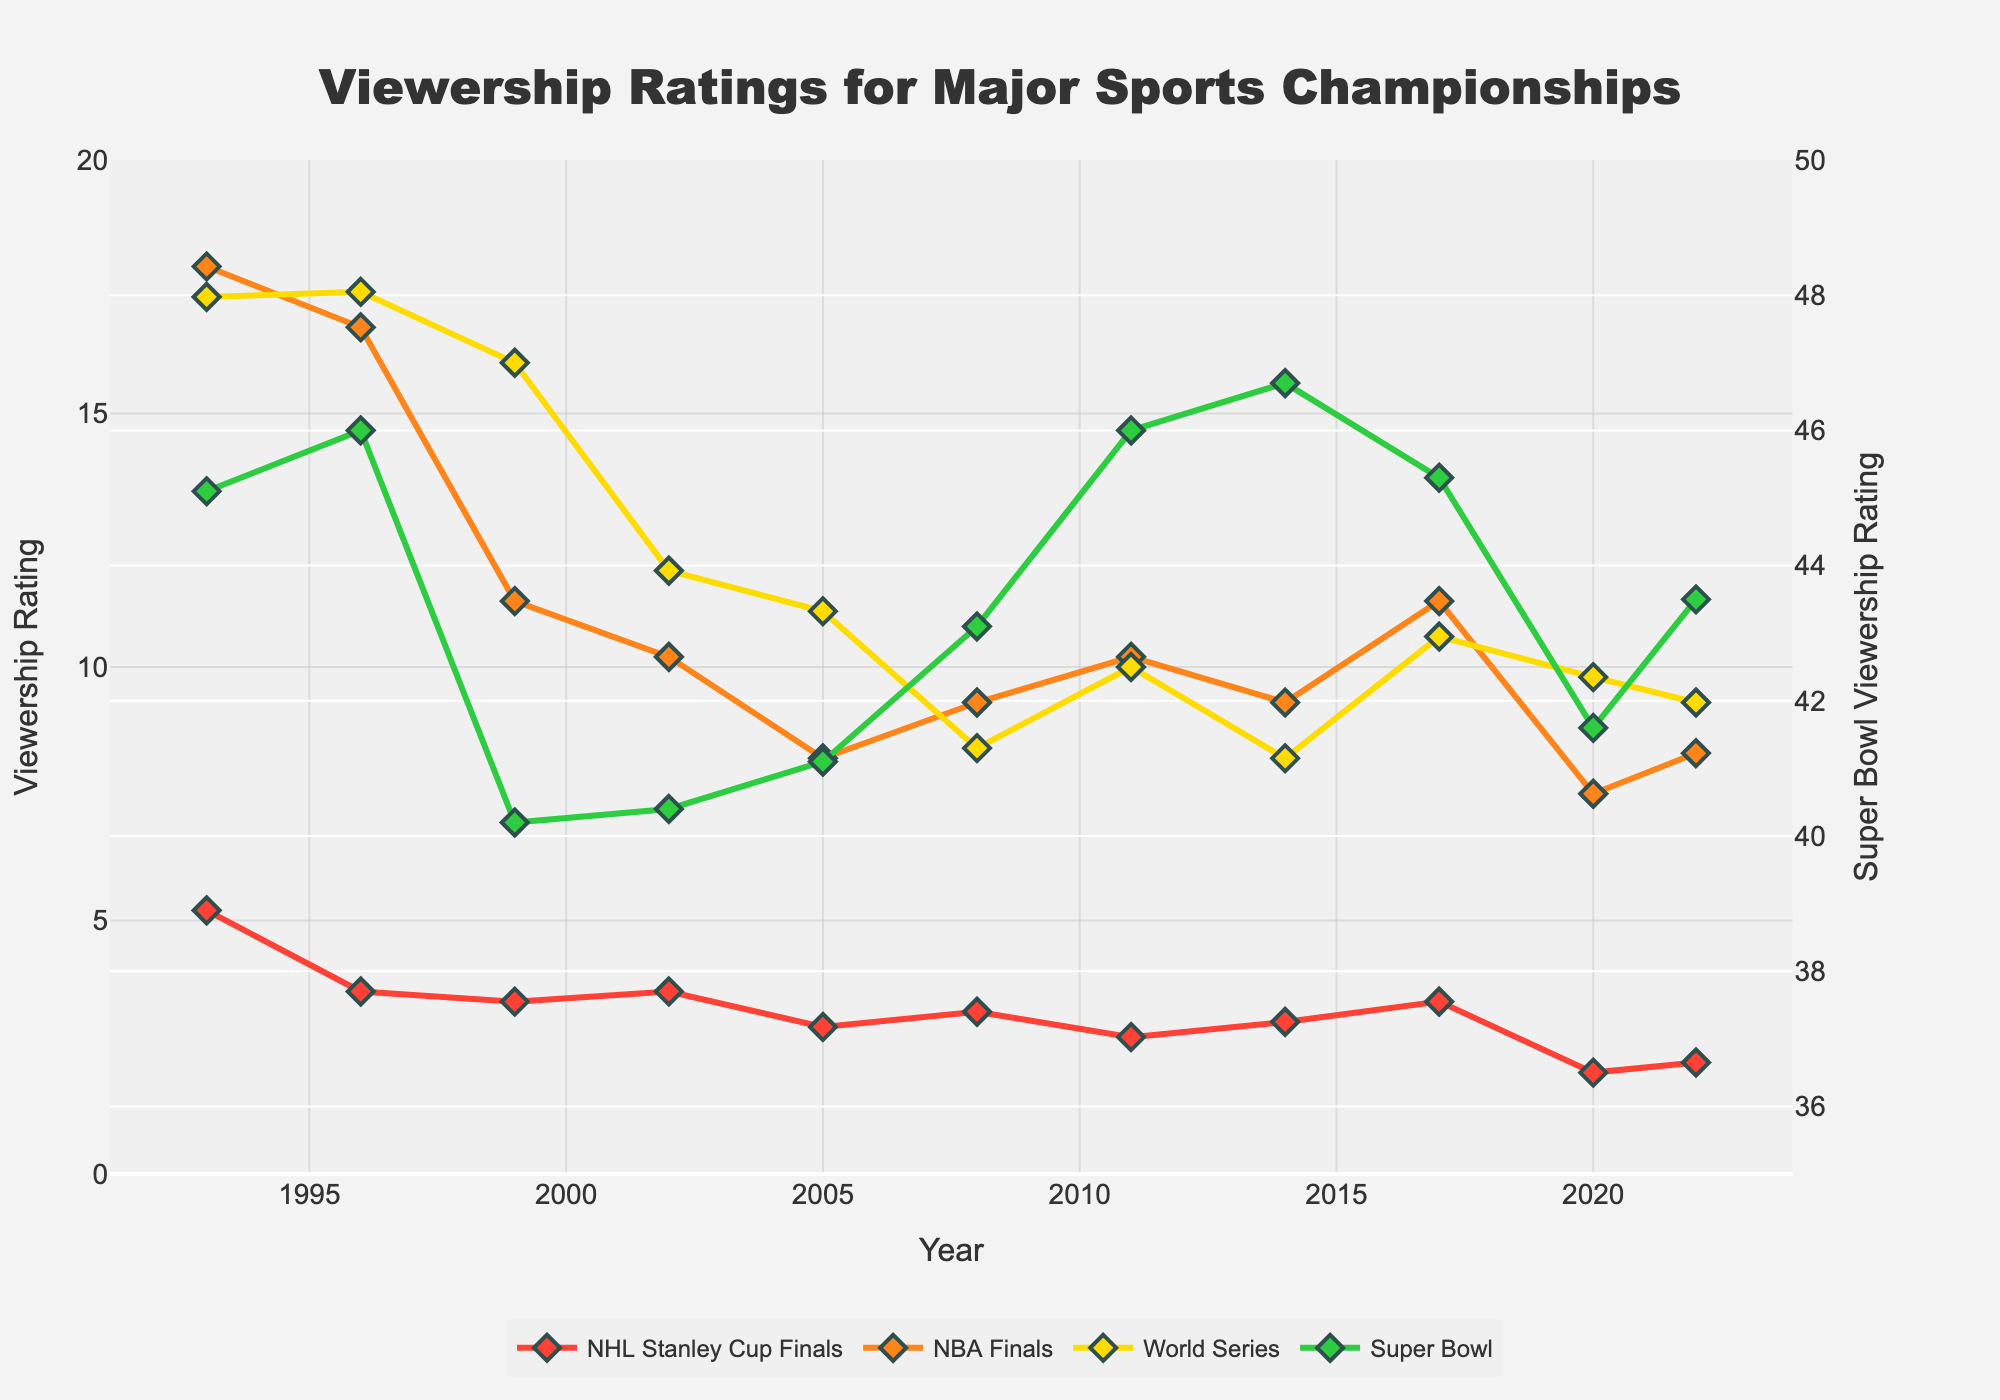Which sport has the highest viewership rating in 2020? To determine the sport with the highest viewership in 2020, look at the data points for each sport in that year on the figure. The Super Bowl has the highest viewership rating of 41.6.
Answer: Super Bowl Between 1996 and 1999, did the NBA Finals viewership increase or decrease, and by how much? To determine the change in NBA Finals viewership from 1996 to 1999, look at the viewership ratings for those years. In 1996, it was 16.7, and in 1999, it was 11.3. So, it decreased by 16.7 - 11.3 = 5.4.
Answer: Decrease by 5.4 What is the average viewership rating for the NHL Stanley Cup Finals from 2002 to 2020? To find the average, add the viewership ratings from 2002 to 2020 and divide by the number of years. (3.6 + 2.9 + 3.2 + 2.7 + 3.0 + 3.4 + 2.0 + 2.2)/8 = 23.0 / 8 = 2.875
Answer: 2.875 Which sport shows the most dramatic decline in viewership from 1993 to 2022? To determine the sport with the most dramatic decline, compare the overall drop for each sport over this period. The NHL Stanley Cup Finals declined from 5.2 in 1993 to 2.2 in 2022, which is a drop of 3.0. The Super Bowl dropped by 1.6 (45.1 to 43.5), the NBA Finals dropped by 9.6 (17.9 to 8.3), and the World Series dropped by 8.0 (17.3 to 9.3). The NBA Finals shows the most significant drop.
Answer: NBA Finals How does the viewership trend for the Super Bowl differ from the trends of the other sports? Look at the lines representing each sport. The Super Bowl maintains a relatively high and stable viewership, with a slight decline in recent years. In contrast, the other sports, especially the NBA Finals and World Series, show a more noticeable decline in viewership over time.
Answer: Super Bowl is stable, others declined Which championship had the lowest viewership rating in 2020? Check the viewership ratings in 2020 for each sport. The NHL Stanley Cup Finals have the lowest rating at 2.0.
Answer: NHL Stanley Cup Finals 